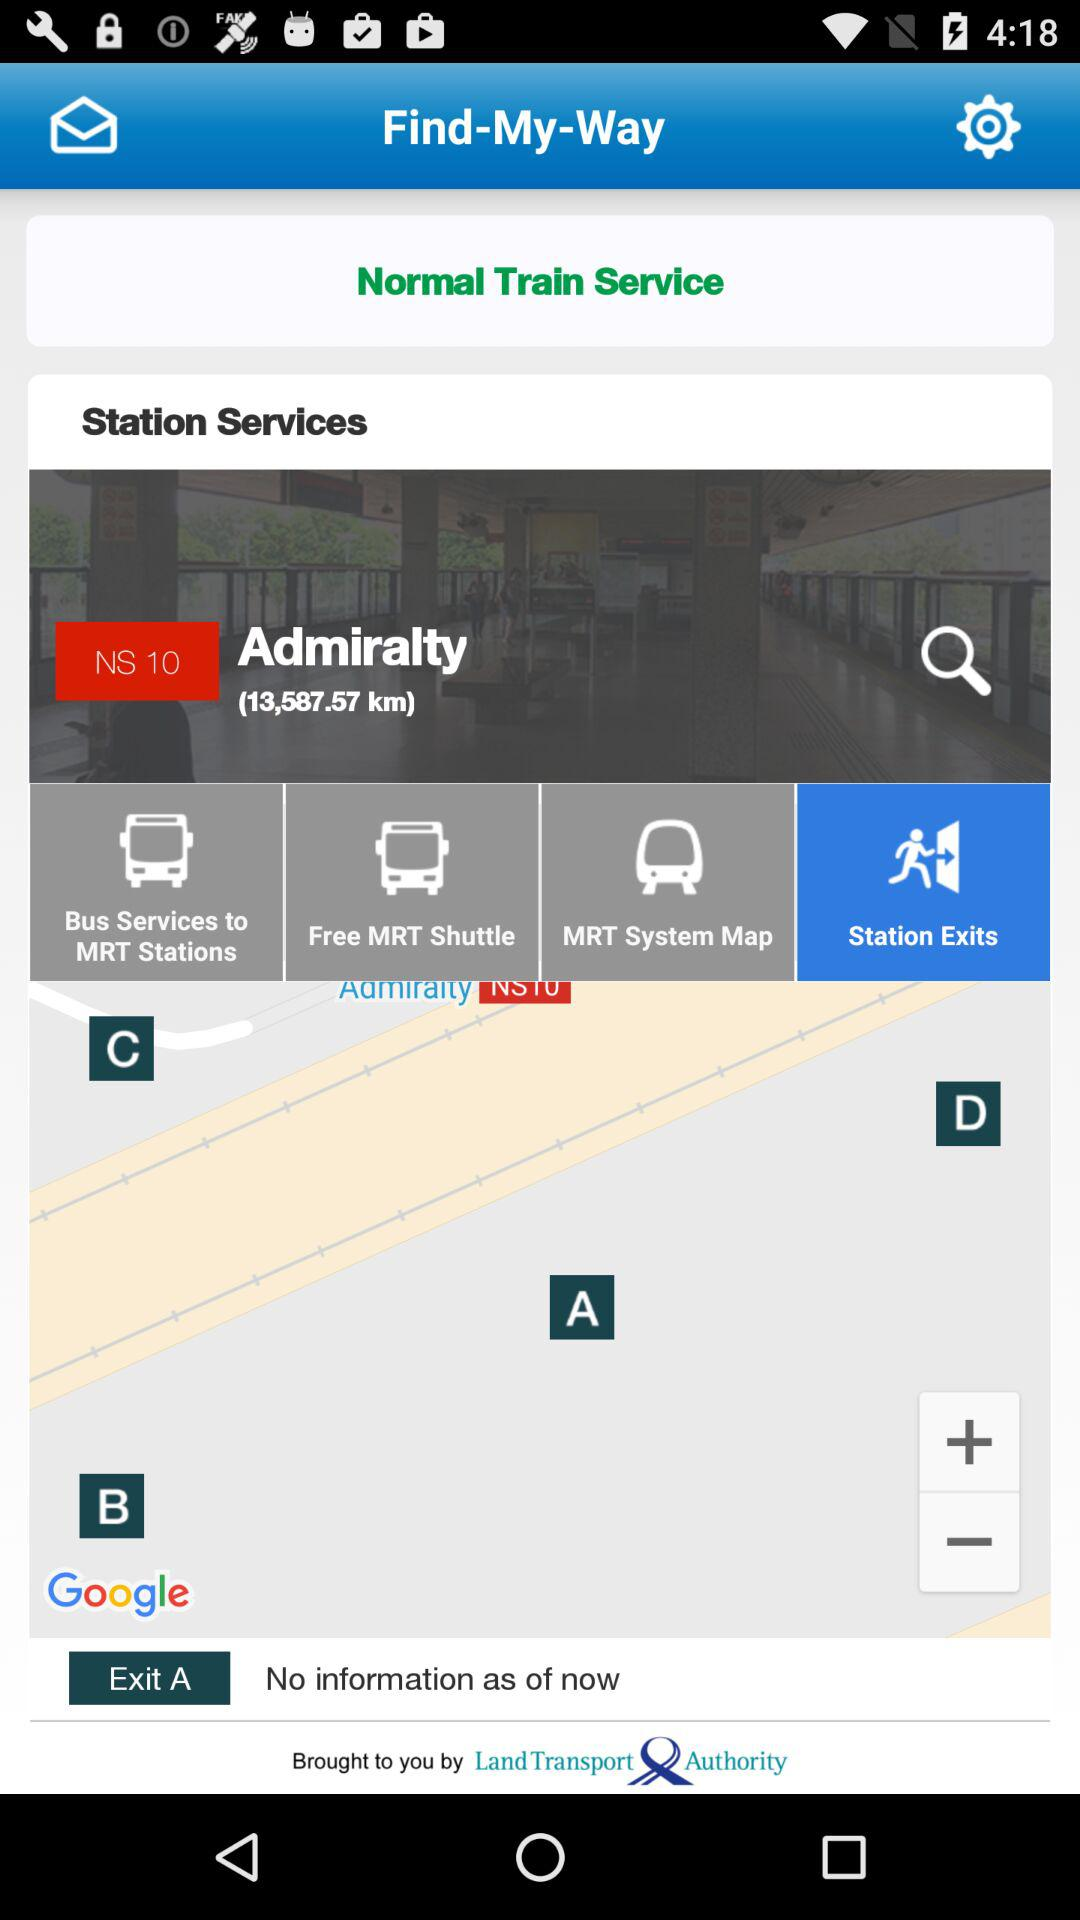What information is given about "Exit A"? There is no given information. 